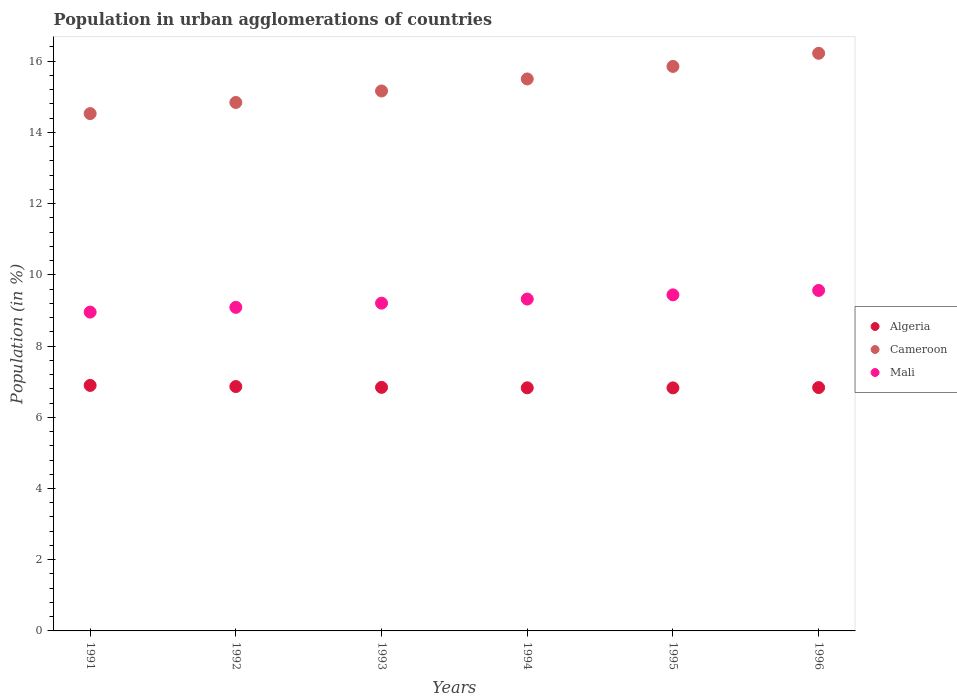Is the number of dotlines equal to the number of legend labels?
Provide a short and direct response. Yes. What is the percentage of population in urban agglomerations in Cameroon in 1991?
Give a very brief answer. 14.53. Across all years, what is the maximum percentage of population in urban agglomerations in Cameroon?
Your answer should be compact. 16.22. Across all years, what is the minimum percentage of population in urban agglomerations in Cameroon?
Provide a short and direct response. 14.53. What is the total percentage of population in urban agglomerations in Cameroon in the graph?
Keep it short and to the point. 92.11. What is the difference between the percentage of population in urban agglomerations in Algeria in 1991 and that in 1993?
Your response must be concise. 0.05. What is the difference between the percentage of population in urban agglomerations in Algeria in 1993 and the percentage of population in urban agglomerations in Cameroon in 1994?
Ensure brevity in your answer.  -8.66. What is the average percentage of population in urban agglomerations in Cameroon per year?
Provide a short and direct response. 15.35. In the year 1991, what is the difference between the percentage of population in urban agglomerations in Mali and percentage of population in urban agglomerations in Cameroon?
Your answer should be compact. -5.58. What is the ratio of the percentage of population in urban agglomerations in Algeria in 1991 to that in 1993?
Offer a very short reply. 1.01. Is the percentage of population in urban agglomerations in Cameroon in 1993 less than that in 1995?
Provide a short and direct response. Yes. What is the difference between the highest and the second highest percentage of population in urban agglomerations in Mali?
Your response must be concise. 0.12. What is the difference between the highest and the lowest percentage of population in urban agglomerations in Mali?
Provide a short and direct response. 0.61. Is the sum of the percentage of population in urban agglomerations in Algeria in 1993 and 1994 greater than the maximum percentage of population in urban agglomerations in Cameroon across all years?
Give a very brief answer. No. Is the percentage of population in urban agglomerations in Cameroon strictly less than the percentage of population in urban agglomerations in Mali over the years?
Your answer should be compact. No. How many years are there in the graph?
Your answer should be very brief. 6. Does the graph contain any zero values?
Provide a succinct answer. No. Does the graph contain grids?
Your response must be concise. No. What is the title of the graph?
Your answer should be very brief. Population in urban agglomerations of countries. What is the label or title of the X-axis?
Provide a short and direct response. Years. What is the label or title of the Y-axis?
Offer a very short reply. Population (in %). What is the Population (in %) of Algeria in 1991?
Make the answer very short. 6.9. What is the Population (in %) of Cameroon in 1991?
Ensure brevity in your answer.  14.53. What is the Population (in %) of Mali in 1991?
Ensure brevity in your answer.  8.95. What is the Population (in %) of Algeria in 1992?
Your answer should be very brief. 6.86. What is the Population (in %) in Cameroon in 1992?
Your answer should be very brief. 14.84. What is the Population (in %) in Mali in 1992?
Offer a very short reply. 9.09. What is the Population (in %) of Algeria in 1993?
Ensure brevity in your answer.  6.84. What is the Population (in %) in Cameroon in 1993?
Provide a short and direct response. 15.16. What is the Population (in %) in Mali in 1993?
Your answer should be compact. 9.21. What is the Population (in %) of Algeria in 1994?
Keep it short and to the point. 6.83. What is the Population (in %) of Cameroon in 1994?
Give a very brief answer. 15.5. What is the Population (in %) of Mali in 1994?
Offer a terse response. 9.32. What is the Population (in %) of Algeria in 1995?
Give a very brief answer. 6.83. What is the Population (in %) of Cameroon in 1995?
Offer a terse response. 15.85. What is the Population (in %) of Mali in 1995?
Your answer should be compact. 9.44. What is the Population (in %) of Algeria in 1996?
Provide a short and direct response. 6.83. What is the Population (in %) in Cameroon in 1996?
Your response must be concise. 16.22. What is the Population (in %) in Mali in 1996?
Your answer should be compact. 9.56. Across all years, what is the maximum Population (in %) in Algeria?
Keep it short and to the point. 6.9. Across all years, what is the maximum Population (in %) of Cameroon?
Offer a very short reply. 16.22. Across all years, what is the maximum Population (in %) of Mali?
Make the answer very short. 9.56. Across all years, what is the minimum Population (in %) of Algeria?
Offer a very short reply. 6.83. Across all years, what is the minimum Population (in %) of Cameroon?
Offer a terse response. 14.53. Across all years, what is the minimum Population (in %) in Mali?
Keep it short and to the point. 8.95. What is the total Population (in %) in Algeria in the graph?
Your answer should be very brief. 41.09. What is the total Population (in %) in Cameroon in the graph?
Offer a very short reply. 92.11. What is the total Population (in %) of Mali in the graph?
Make the answer very short. 55.57. What is the difference between the Population (in %) of Algeria in 1991 and that in 1992?
Offer a very short reply. 0.03. What is the difference between the Population (in %) of Cameroon in 1991 and that in 1992?
Provide a succinct answer. -0.31. What is the difference between the Population (in %) in Mali in 1991 and that in 1992?
Keep it short and to the point. -0.13. What is the difference between the Population (in %) of Algeria in 1991 and that in 1993?
Keep it short and to the point. 0.05. What is the difference between the Population (in %) of Cameroon in 1991 and that in 1993?
Make the answer very short. -0.64. What is the difference between the Population (in %) of Mali in 1991 and that in 1993?
Your answer should be compact. -0.25. What is the difference between the Population (in %) in Algeria in 1991 and that in 1994?
Offer a very short reply. 0.07. What is the difference between the Population (in %) of Cameroon in 1991 and that in 1994?
Give a very brief answer. -0.97. What is the difference between the Population (in %) of Mali in 1991 and that in 1994?
Make the answer very short. -0.37. What is the difference between the Population (in %) in Algeria in 1991 and that in 1995?
Make the answer very short. 0.07. What is the difference between the Population (in %) in Cameroon in 1991 and that in 1995?
Make the answer very short. -1.32. What is the difference between the Population (in %) in Mali in 1991 and that in 1995?
Your answer should be very brief. -0.48. What is the difference between the Population (in %) in Algeria in 1991 and that in 1996?
Offer a terse response. 0.06. What is the difference between the Population (in %) of Cameroon in 1991 and that in 1996?
Your response must be concise. -1.69. What is the difference between the Population (in %) of Mali in 1991 and that in 1996?
Your answer should be very brief. -0.61. What is the difference between the Population (in %) of Algeria in 1992 and that in 1993?
Provide a short and direct response. 0.02. What is the difference between the Population (in %) in Cameroon in 1992 and that in 1993?
Provide a succinct answer. -0.32. What is the difference between the Population (in %) in Mali in 1992 and that in 1993?
Provide a short and direct response. -0.12. What is the difference between the Population (in %) in Algeria in 1992 and that in 1994?
Give a very brief answer. 0.04. What is the difference between the Population (in %) of Cameroon in 1992 and that in 1994?
Give a very brief answer. -0.66. What is the difference between the Population (in %) of Mali in 1992 and that in 1994?
Your response must be concise. -0.23. What is the difference between the Population (in %) of Algeria in 1992 and that in 1995?
Offer a very short reply. 0.04. What is the difference between the Population (in %) of Cameroon in 1992 and that in 1995?
Offer a terse response. -1.01. What is the difference between the Population (in %) in Mali in 1992 and that in 1995?
Make the answer very short. -0.35. What is the difference between the Population (in %) of Algeria in 1992 and that in 1996?
Make the answer very short. 0.03. What is the difference between the Population (in %) of Cameroon in 1992 and that in 1996?
Make the answer very short. -1.38. What is the difference between the Population (in %) of Mali in 1992 and that in 1996?
Give a very brief answer. -0.47. What is the difference between the Population (in %) of Algeria in 1993 and that in 1994?
Make the answer very short. 0.01. What is the difference between the Population (in %) in Cameroon in 1993 and that in 1994?
Provide a succinct answer. -0.34. What is the difference between the Population (in %) of Mali in 1993 and that in 1994?
Offer a very short reply. -0.11. What is the difference between the Population (in %) in Algeria in 1993 and that in 1995?
Provide a succinct answer. 0.01. What is the difference between the Population (in %) in Cameroon in 1993 and that in 1995?
Provide a succinct answer. -0.69. What is the difference between the Population (in %) in Mali in 1993 and that in 1995?
Provide a succinct answer. -0.23. What is the difference between the Population (in %) of Algeria in 1993 and that in 1996?
Give a very brief answer. 0.01. What is the difference between the Population (in %) in Cameroon in 1993 and that in 1996?
Ensure brevity in your answer.  -1.06. What is the difference between the Population (in %) of Mali in 1993 and that in 1996?
Offer a very short reply. -0.36. What is the difference between the Population (in %) in Algeria in 1994 and that in 1995?
Provide a succinct answer. 0. What is the difference between the Population (in %) in Cameroon in 1994 and that in 1995?
Offer a terse response. -0.35. What is the difference between the Population (in %) of Mali in 1994 and that in 1995?
Make the answer very short. -0.12. What is the difference between the Population (in %) of Algeria in 1994 and that in 1996?
Make the answer very short. -0.01. What is the difference between the Population (in %) in Cameroon in 1994 and that in 1996?
Provide a succinct answer. -0.72. What is the difference between the Population (in %) of Mali in 1994 and that in 1996?
Provide a succinct answer. -0.24. What is the difference between the Population (in %) of Algeria in 1995 and that in 1996?
Your response must be concise. -0.01. What is the difference between the Population (in %) in Cameroon in 1995 and that in 1996?
Your answer should be very brief. -0.37. What is the difference between the Population (in %) of Mali in 1995 and that in 1996?
Provide a short and direct response. -0.12. What is the difference between the Population (in %) in Algeria in 1991 and the Population (in %) in Cameroon in 1992?
Offer a very short reply. -7.95. What is the difference between the Population (in %) in Algeria in 1991 and the Population (in %) in Mali in 1992?
Your answer should be compact. -2.19. What is the difference between the Population (in %) of Cameroon in 1991 and the Population (in %) of Mali in 1992?
Offer a very short reply. 5.44. What is the difference between the Population (in %) of Algeria in 1991 and the Population (in %) of Cameroon in 1993?
Your answer should be very brief. -8.27. What is the difference between the Population (in %) in Algeria in 1991 and the Population (in %) in Mali in 1993?
Ensure brevity in your answer.  -2.31. What is the difference between the Population (in %) in Cameroon in 1991 and the Population (in %) in Mali in 1993?
Give a very brief answer. 5.32. What is the difference between the Population (in %) in Algeria in 1991 and the Population (in %) in Cameroon in 1994?
Your answer should be compact. -8.61. What is the difference between the Population (in %) in Algeria in 1991 and the Population (in %) in Mali in 1994?
Provide a short and direct response. -2.43. What is the difference between the Population (in %) of Cameroon in 1991 and the Population (in %) of Mali in 1994?
Make the answer very short. 5.21. What is the difference between the Population (in %) in Algeria in 1991 and the Population (in %) in Cameroon in 1995?
Ensure brevity in your answer.  -8.96. What is the difference between the Population (in %) of Algeria in 1991 and the Population (in %) of Mali in 1995?
Keep it short and to the point. -2.54. What is the difference between the Population (in %) of Cameroon in 1991 and the Population (in %) of Mali in 1995?
Your answer should be compact. 5.09. What is the difference between the Population (in %) of Algeria in 1991 and the Population (in %) of Cameroon in 1996?
Keep it short and to the point. -9.33. What is the difference between the Population (in %) of Algeria in 1991 and the Population (in %) of Mali in 1996?
Provide a short and direct response. -2.67. What is the difference between the Population (in %) of Cameroon in 1991 and the Population (in %) of Mali in 1996?
Your response must be concise. 4.97. What is the difference between the Population (in %) in Algeria in 1992 and the Population (in %) in Cameroon in 1993?
Your answer should be very brief. -8.3. What is the difference between the Population (in %) of Algeria in 1992 and the Population (in %) of Mali in 1993?
Provide a succinct answer. -2.34. What is the difference between the Population (in %) in Cameroon in 1992 and the Population (in %) in Mali in 1993?
Offer a very short reply. 5.64. What is the difference between the Population (in %) of Algeria in 1992 and the Population (in %) of Cameroon in 1994?
Your answer should be very brief. -8.64. What is the difference between the Population (in %) in Algeria in 1992 and the Population (in %) in Mali in 1994?
Offer a terse response. -2.46. What is the difference between the Population (in %) in Cameroon in 1992 and the Population (in %) in Mali in 1994?
Keep it short and to the point. 5.52. What is the difference between the Population (in %) of Algeria in 1992 and the Population (in %) of Cameroon in 1995?
Ensure brevity in your answer.  -8.99. What is the difference between the Population (in %) of Algeria in 1992 and the Population (in %) of Mali in 1995?
Keep it short and to the point. -2.58. What is the difference between the Population (in %) of Cameroon in 1992 and the Population (in %) of Mali in 1995?
Offer a terse response. 5.4. What is the difference between the Population (in %) in Algeria in 1992 and the Population (in %) in Cameroon in 1996?
Keep it short and to the point. -9.36. What is the difference between the Population (in %) of Algeria in 1992 and the Population (in %) of Mali in 1996?
Offer a very short reply. -2.7. What is the difference between the Population (in %) of Cameroon in 1992 and the Population (in %) of Mali in 1996?
Provide a succinct answer. 5.28. What is the difference between the Population (in %) of Algeria in 1993 and the Population (in %) of Cameroon in 1994?
Your answer should be very brief. -8.66. What is the difference between the Population (in %) in Algeria in 1993 and the Population (in %) in Mali in 1994?
Offer a very short reply. -2.48. What is the difference between the Population (in %) of Cameroon in 1993 and the Population (in %) of Mali in 1994?
Your answer should be compact. 5.84. What is the difference between the Population (in %) of Algeria in 1993 and the Population (in %) of Cameroon in 1995?
Make the answer very short. -9.01. What is the difference between the Population (in %) in Algeria in 1993 and the Population (in %) in Mali in 1995?
Offer a terse response. -2.6. What is the difference between the Population (in %) in Cameroon in 1993 and the Population (in %) in Mali in 1995?
Offer a terse response. 5.73. What is the difference between the Population (in %) of Algeria in 1993 and the Population (in %) of Cameroon in 1996?
Keep it short and to the point. -9.38. What is the difference between the Population (in %) in Algeria in 1993 and the Population (in %) in Mali in 1996?
Make the answer very short. -2.72. What is the difference between the Population (in %) in Cameroon in 1993 and the Population (in %) in Mali in 1996?
Make the answer very short. 5.6. What is the difference between the Population (in %) of Algeria in 1994 and the Population (in %) of Cameroon in 1995?
Offer a terse response. -9.03. What is the difference between the Population (in %) of Algeria in 1994 and the Population (in %) of Mali in 1995?
Provide a succinct answer. -2.61. What is the difference between the Population (in %) in Cameroon in 1994 and the Population (in %) in Mali in 1995?
Your response must be concise. 6.06. What is the difference between the Population (in %) in Algeria in 1994 and the Population (in %) in Cameroon in 1996?
Ensure brevity in your answer.  -9.39. What is the difference between the Population (in %) in Algeria in 1994 and the Population (in %) in Mali in 1996?
Make the answer very short. -2.73. What is the difference between the Population (in %) of Cameroon in 1994 and the Population (in %) of Mali in 1996?
Provide a short and direct response. 5.94. What is the difference between the Population (in %) of Algeria in 1995 and the Population (in %) of Cameroon in 1996?
Your answer should be very brief. -9.4. What is the difference between the Population (in %) in Algeria in 1995 and the Population (in %) in Mali in 1996?
Your answer should be very brief. -2.74. What is the difference between the Population (in %) in Cameroon in 1995 and the Population (in %) in Mali in 1996?
Your response must be concise. 6.29. What is the average Population (in %) in Algeria per year?
Make the answer very short. 6.85. What is the average Population (in %) of Cameroon per year?
Provide a succinct answer. 15.35. What is the average Population (in %) in Mali per year?
Keep it short and to the point. 9.26. In the year 1991, what is the difference between the Population (in %) of Algeria and Population (in %) of Cameroon?
Your answer should be compact. -7.63. In the year 1991, what is the difference between the Population (in %) in Algeria and Population (in %) in Mali?
Keep it short and to the point. -2.06. In the year 1991, what is the difference between the Population (in %) of Cameroon and Population (in %) of Mali?
Your answer should be very brief. 5.58. In the year 1992, what is the difference between the Population (in %) in Algeria and Population (in %) in Cameroon?
Ensure brevity in your answer.  -7.98. In the year 1992, what is the difference between the Population (in %) in Algeria and Population (in %) in Mali?
Provide a short and direct response. -2.22. In the year 1992, what is the difference between the Population (in %) of Cameroon and Population (in %) of Mali?
Your answer should be compact. 5.75. In the year 1993, what is the difference between the Population (in %) in Algeria and Population (in %) in Cameroon?
Provide a short and direct response. -8.32. In the year 1993, what is the difference between the Population (in %) in Algeria and Population (in %) in Mali?
Your response must be concise. -2.37. In the year 1993, what is the difference between the Population (in %) of Cameroon and Population (in %) of Mali?
Ensure brevity in your answer.  5.96. In the year 1994, what is the difference between the Population (in %) in Algeria and Population (in %) in Cameroon?
Your answer should be very brief. -8.67. In the year 1994, what is the difference between the Population (in %) in Algeria and Population (in %) in Mali?
Offer a very short reply. -2.49. In the year 1994, what is the difference between the Population (in %) in Cameroon and Population (in %) in Mali?
Your response must be concise. 6.18. In the year 1995, what is the difference between the Population (in %) in Algeria and Population (in %) in Cameroon?
Make the answer very short. -9.03. In the year 1995, what is the difference between the Population (in %) of Algeria and Population (in %) of Mali?
Give a very brief answer. -2.61. In the year 1995, what is the difference between the Population (in %) of Cameroon and Population (in %) of Mali?
Your answer should be very brief. 6.42. In the year 1996, what is the difference between the Population (in %) in Algeria and Population (in %) in Cameroon?
Your answer should be very brief. -9.39. In the year 1996, what is the difference between the Population (in %) of Algeria and Population (in %) of Mali?
Your answer should be very brief. -2.73. In the year 1996, what is the difference between the Population (in %) in Cameroon and Population (in %) in Mali?
Your answer should be compact. 6.66. What is the ratio of the Population (in %) of Algeria in 1991 to that in 1992?
Your answer should be compact. 1. What is the ratio of the Population (in %) of Cameroon in 1991 to that in 1993?
Ensure brevity in your answer.  0.96. What is the ratio of the Population (in %) of Mali in 1991 to that in 1993?
Provide a short and direct response. 0.97. What is the ratio of the Population (in %) in Algeria in 1991 to that in 1994?
Offer a terse response. 1.01. What is the ratio of the Population (in %) in Cameroon in 1991 to that in 1994?
Ensure brevity in your answer.  0.94. What is the ratio of the Population (in %) of Mali in 1991 to that in 1994?
Provide a succinct answer. 0.96. What is the ratio of the Population (in %) of Algeria in 1991 to that in 1995?
Provide a short and direct response. 1.01. What is the ratio of the Population (in %) of Cameroon in 1991 to that in 1995?
Keep it short and to the point. 0.92. What is the ratio of the Population (in %) of Mali in 1991 to that in 1995?
Provide a short and direct response. 0.95. What is the ratio of the Population (in %) in Algeria in 1991 to that in 1996?
Keep it short and to the point. 1.01. What is the ratio of the Population (in %) in Cameroon in 1991 to that in 1996?
Offer a terse response. 0.9. What is the ratio of the Population (in %) of Mali in 1991 to that in 1996?
Ensure brevity in your answer.  0.94. What is the ratio of the Population (in %) of Algeria in 1992 to that in 1993?
Your answer should be very brief. 1. What is the ratio of the Population (in %) in Cameroon in 1992 to that in 1993?
Provide a succinct answer. 0.98. What is the ratio of the Population (in %) of Mali in 1992 to that in 1993?
Ensure brevity in your answer.  0.99. What is the ratio of the Population (in %) of Algeria in 1992 to that in 1994?
Your answer should be compact. 1.01. What is the ratio of the Population (in %) in Cameroon in 1992 to that in 1994?
Keep it short and to the point. 0.96. What is the ratio of the Population (in %) of Mali in 1992 to that in 1994?
Provide a succinct answer. 0.97. What is the ratio of the Population (in %) of Cameroon in 1992 to that in 1995?
Provide a short and direct response. 0.94. What is the ratio of the Population (in %) in Mali in 1992 to that in 1995?
Ensure brevity in your answer.  0.96. What is the ratio of the Population (in %) of Algeria in 1992 to that in 1996?
Offer a very short reply. 1. What is the ratio of the Population (in %) of Cameroon in 1992 to that in 1996?
Ensure brevity in your answer.  0.91. What is the ratio of the Population (in %) in Mali in 1992 to that in 1996?
Your answer should be compact. 0.95. What is the ratio of the Population (in %) in Cameroon in 1993 to that in 1994?
Offer a terse response. 0.98. What is the ratio of the Population (in %) in Algeria in 1993 to that in 1995?
Your response must be concise. 1. What is the ratio of the Population (in %) in Cameroon in 1993 to that in 1995?
Offer a very short reply. 0.96. What is the ratio of the Population (in %) in Mali in 1993 to that in 1995?
Make the answer very short. 0.98. What is the ratio of the Population (in %) of Algeria in 1993 to that in 1996?
Offer a very short reply. 1. What is the ratio of the Population (in %) in Cameroon in 1993 to that in 1996?
Your response must be concise. 0.93. What is the ratio of the Population (in %) in Mali in 1993 to that in 1996?
Provide a succinct answer. 0.96. What is the ratio of the Population (in %) in Algeria in 1994 to that in 1995?
Keep it short and to the point. 1. What is the ratio of the Population (in %) of Cameroon in 1994 to that in 1995?
Keep it short and to the point. 0.98. What is the ratio of the Population (in %) in Mali in 1994 to that in 1995?
Provide a short and direct response. 0.99. What is the ratio of the Population (in %) of Cameroon in 1994 to that in 1996?
Offer a very short reply. 0.96. What is the ratio of the Population (in %) of Mali in 1994 to that in 1996?
Make the answer very short. 0.97. What is the ratio of the Population (in %) in Cameroon in 1995 to that in 1996?
Offer a terse response. 0.98. What is the ratio of the Population (in %) of Mali in 1995 to that in 1996?
Provide a short and direct response. 0.99. What is the difference between the highest and the second highest Population (in %) of Algeria?
Offer a terse response. 0.03. What is the difference between the highest and the second highest Population (in %) in Cameroon?
Your answer should be very brief. 0.37. What is the difference between the highest and the second highest Population (in %) of Mali?
Keep it short and to the point. 0.12. What is the difference between the highest and the lowest Population (in %) in Algeria?
Your answer should be compact. 0.07. What is the difference between the highest and the lowest Population (in %) in Cameroon?
Your answer should be compact. 1.69. What is the difference between the highest and the lowest Population (in %) in Mali?
Offer a terse response. 0.61. 